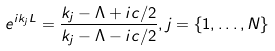<formula> <loc_0><loc_0><loc_500><loc_500>e ^ { i k _ { j } L } = \frac { k _ { j } - \Lambda + i c / 2 } { k _ { j } - \Lambda - i c / 2 } , j = \{ 1 , \dots , N \}</formula> 